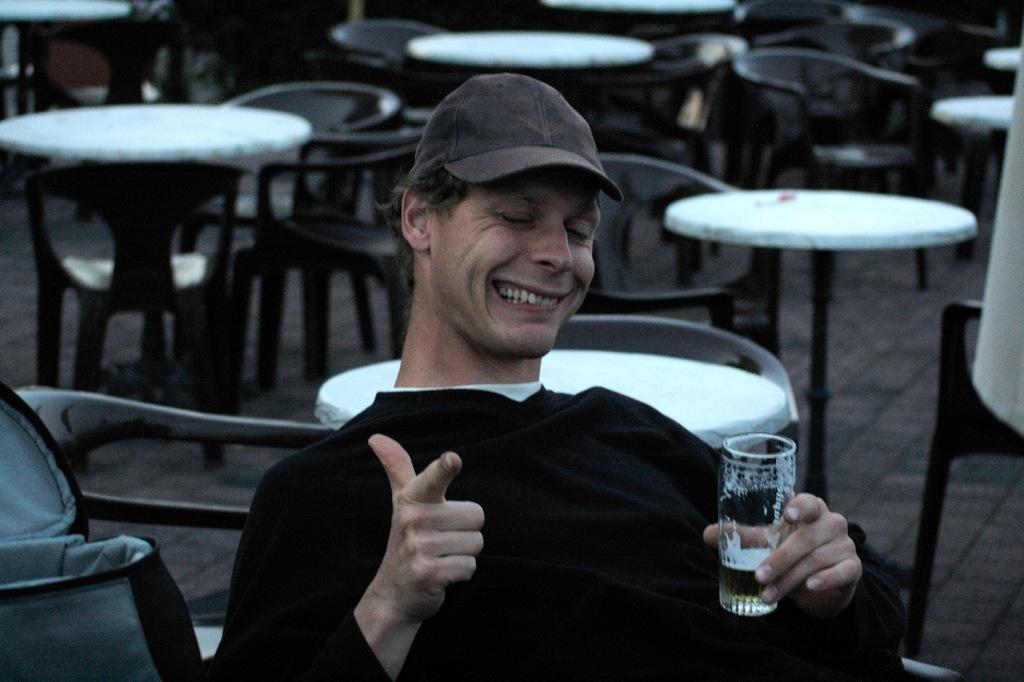How would you summarize this image in a sentence or two? In this picture, we see a man is wearing the black T-shirt and a cap. He is holding a glass containing the liquid in his hand. He is pointing his finger towards something. He is smiling and he might be posing for the photo. On the left side, we see a chair on which a grey and black color bag is placed. Behind him, we see the empty chairs and tables. On the right side, we see a cloth in white color. 